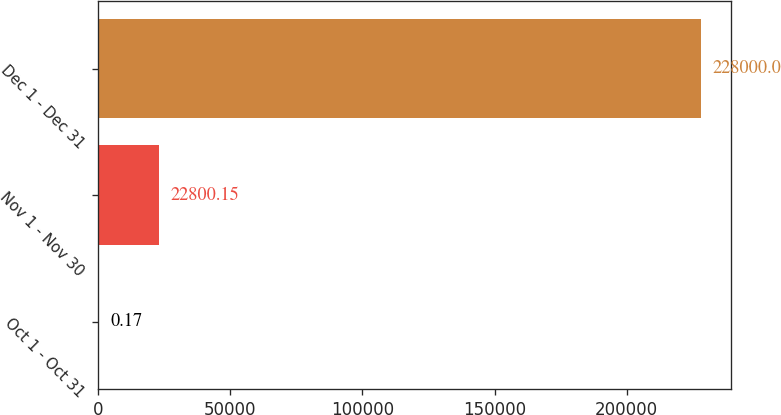Convert chart. <chart><loc_0><loc_0><loc_500><loc_500><bar_chart><fcel>Oct 1 - Oct 31<fcel>Nov 1 - Nov 30<fcel>Dec 1 - Dec 31<nl><fcel>0.17<fcel>22800.2<fcel>228000<nl></chart> 